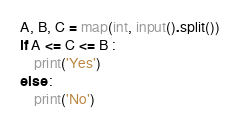Convert code to text. <code><loc_0><loc_0><loc_500><loc_500><_Python_>A, B, C = map(int, input().split())
if A <= C <= B :
    print('Yes')
else :
    print('No')</code> 